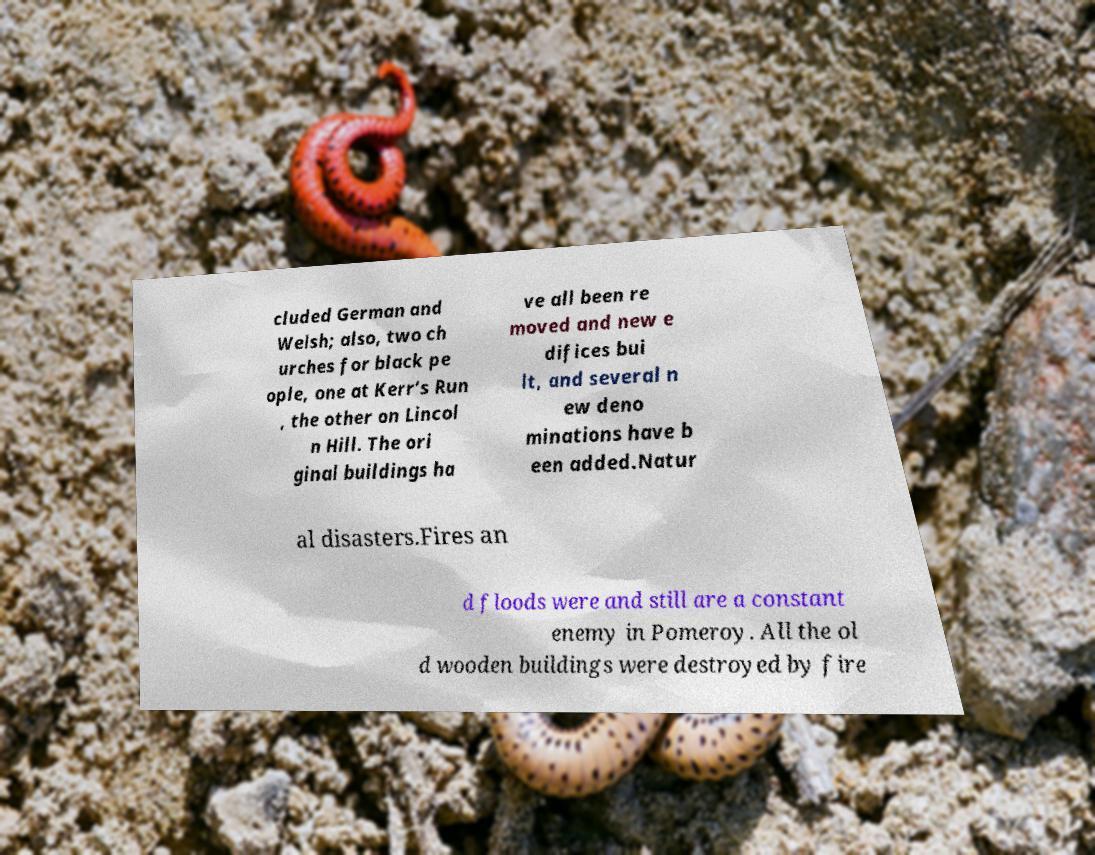There's text embedded in this image that I need extracted. Can you transcribe it verbatim? cluded German and Welsh; also, two ch urches for black pe ople, one at Kerr’s Run , the other on Lincol n Hill. The ori ginal buildings ha ve all been re moved and new e difices bui lt, and several n ew deno minations have b een added.Natur al disasters.Fires an d floods were and still are a constant enemy in Pomeroy. All the ol d wooden buildings were destroyed by fire 